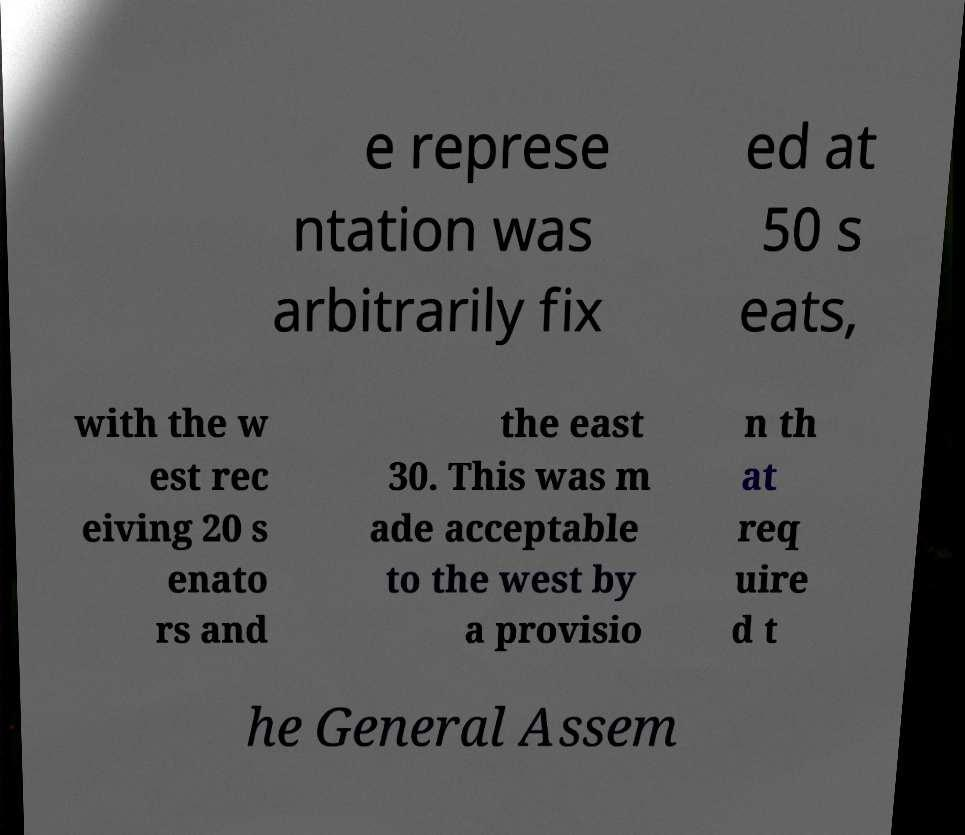Can you accurately transcribe the text from the provided image for me? e represe ntation was arbitrarily fix ed at 50 s eats, with the w est rec eiving 20 s enato rs and the east 30. This was m ade acceptable to the west by a provisio n th at req uire d t he General Assem 